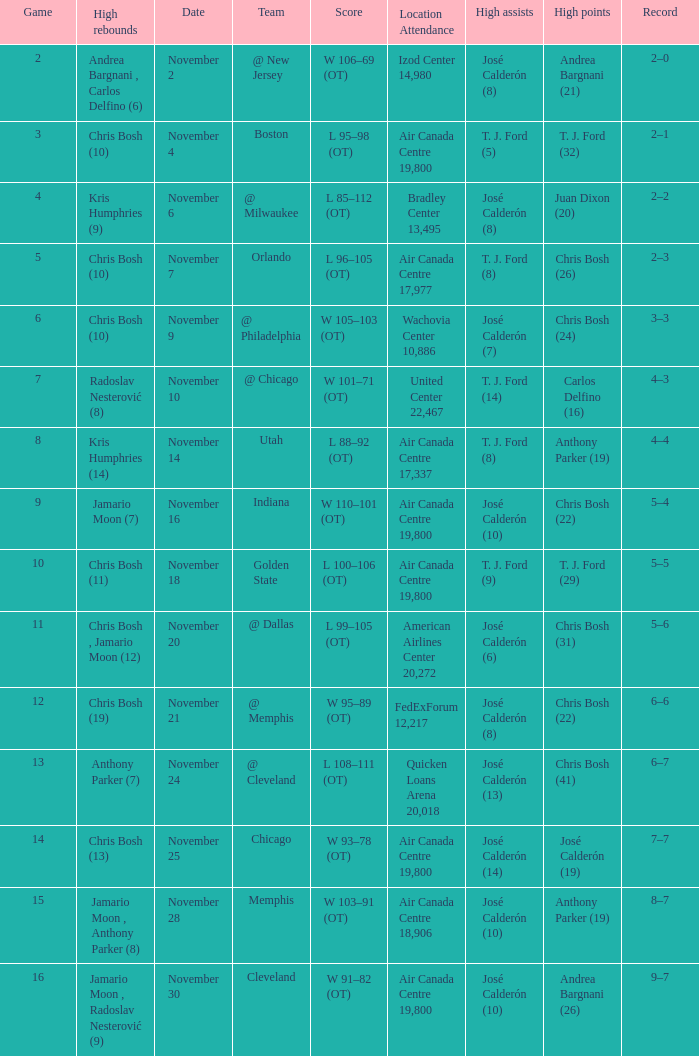Who had the high rebounds when the game number was 6? Chris Bosh (10). 